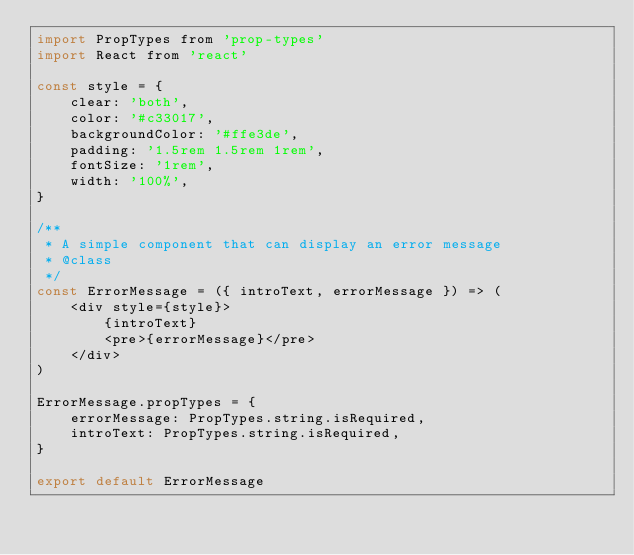<code> <loc_0><loc_0><loc_500><loc_500><_JavaScript_>import PropTypes from 'prop-types'
import React from 'react'

const style = {
    clear: 'both',
    color: '#c33017',
    backgroundColor: '#ffe3de',
    padding: '1.5rem 1.5rem 1rem',
    fontSize: '1rem',
    width: '100%',
}

/**
 * A simple component that can display an error message
 * @class
 */
const ErrorMessage = ({ introText, errorMessage }) => (
    <div style={style}>
        {introText}
        <pre>{errorMessage}</pre>
    </div>
)

ErrorMessage.propTypes = {
    errorMessage: PropTypes.string.isRequired,
    introText: PropTypes.string.isRequired,
}

export default ErrorMessage
</code> 